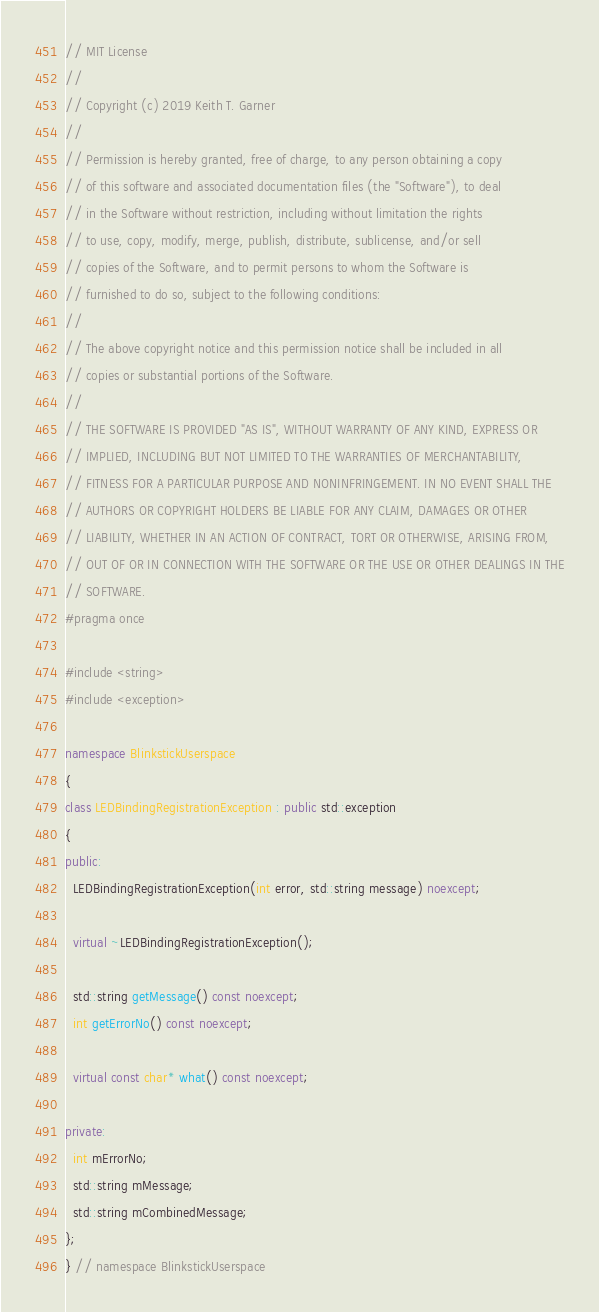Convert code to text. <code><loc_0><loc_0><loc_500><loc_500><_C++_>// MIT License
//
// Copyright (c) 2019 Keith T. Garner
//
// Permission is hereby granted, free of charge, to any person obtaining a copy
// of this software and associated documentation files (the "Software"), to deal
// in the Software without restriction, including without limitation the rights
// to use, copy, modify, merge, publish, distribute, sublicense, and/or sell
// copies of the Software, and to permit persons to whom the Software is
// furnished to do so, subject to the following conditions:
//
// The above copyright notice and this permission notice shall be included in all
// copies or substantial portions of the Software.
//
// THE SOFTWARE IS PROVIDED "AS IS", WITHOUT WARRANTY OF ANY KIND, EXPRESS OR
// IMPLIED, INCLUDING BUT NOT LIMITED TO THE WARRANTIES OF MERCHANTABILITY,
// FITNESS FOR A PARTICULAR PURPOSE AND NONINFRINGEMENT. IN NO EVENT SHALL THE
// AUTHORS OR COPYRIGHT HOLDERS BE LIABLE FOR ANY CLAIM, DAMAGES OR OTHER
// LIABILITY, WHETHER IN AN ACTION OF CONTRACT, TORT OR OTHERWISE, ARISING FROM,
// OUT OF OR IN CONNECTION WITH THE SOFTWARE OR THE USE OR OTHER DEALINGS IN THE
// SOFTWARE.
#pragma once

#include <string>
#include <exception>

namespace BlinkstickUserspace
{
class LEDBindingRegistrationException : public std::exception
{
public:
  LEDBindingRegistrationException(int error, std::string message) noexcept;

  virtual ~LEDBindingRegistrationException();

  std::string getMessage() const noexcept;
  int getErrorNo() const noexcept;

  virtual const char* what() const noexcept;

private:
  int mErrorNo;
  std::string mMessage;
  std::string mCombinedMessage;
};
} // namespace BlinkstickUserspace
</code> 